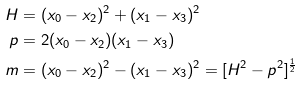<formula> <loc_0><loc_0><loc_500><loc_500>H & = ( x _ { 0 } - x _ { 2 } ) ^ { 2 } + ( x _ { 1 } - x _ { 3 } ) ^ { 2 } \\ p & = 2 ( x _ { 0 } - x _ { 2 } ) ( x _ { 1 } - x _ { 3 } ) \\ m & = ( x _ { 0 } - x _ { 2 } ) ^ { 2 } - ( x _ { 1 } - x _ { 3 } ) ^ { 2 } = [ H ^ { 2 } - p ^ { 2 } ] ^ { \frac { 1 } { 2 } }</formula> 